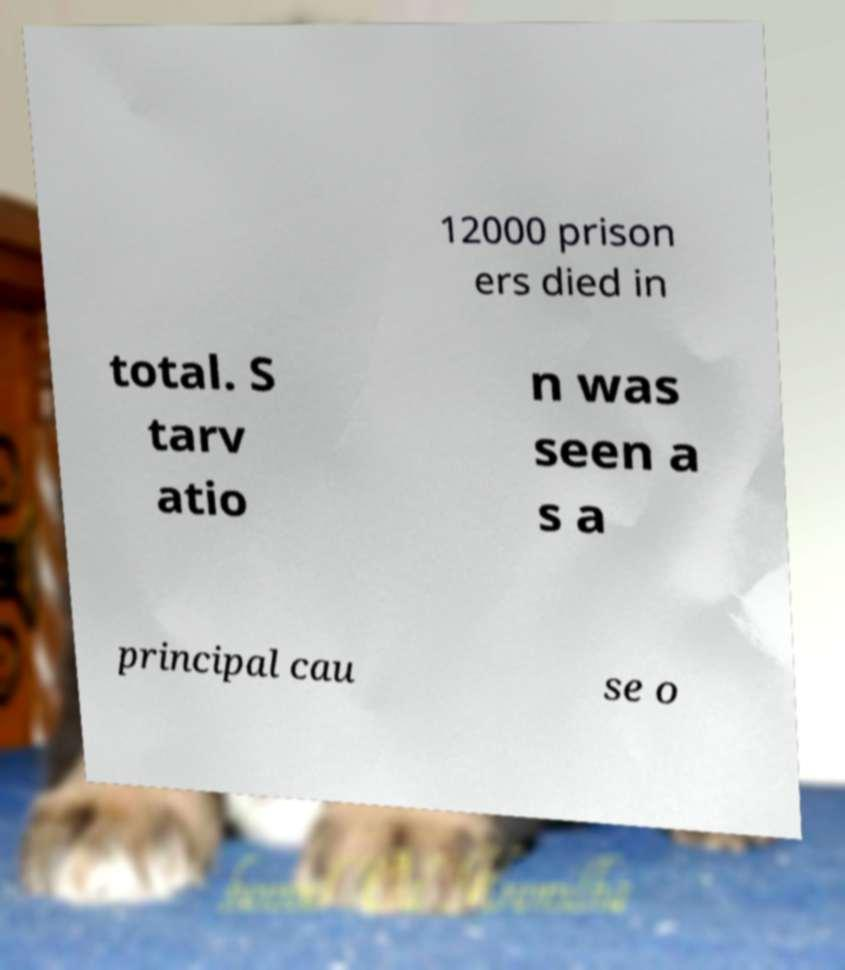Could you extract and type out the text from this image? 12000 prison ers died in total. S tarv atio n was seen a s a principal cau se o 